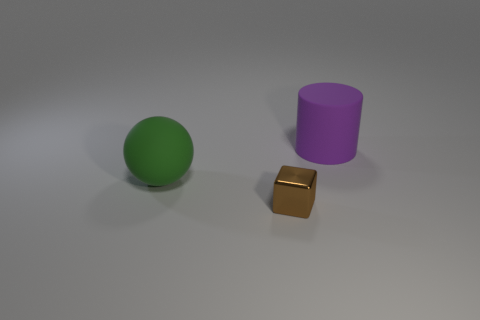Are there more large things on the left side of the shiny cube than brown cylinders?
Make the answer very short. Yes. How many other objects are the same color as the small metallic object?
Keep it short and to the point. 0. Is the size of the rubber thing that is behind the green matte sphere the same as the green thing?
Keep it short and to the point. Yes. Is there a green rubber ball of the same size as the purple matte cylinder?
Ensure brevity in your answer.  Yes. What is the color of the object right of the metal cube?
Give a very brief answer. Purple. There is a thing that is both on the right side of the green sphere and left of the purple cylinder; what shape is it?
Offer a terse response. Cube. How many tiny blue cylinders are there?
Your answer should be very brief. 0. There is a object that is behind the tiny brown metallic cube and right of the green matte sphere; how big is it?
Your answer should be very brief. Large. There is a green thing that is the same size as the purple thing; what is its shape?
Provide a succinct answer. Sphere. There is a large thing that is in front of the purple rubber object; is there a purple thing right of it?
Your response must be concise. Yes. 